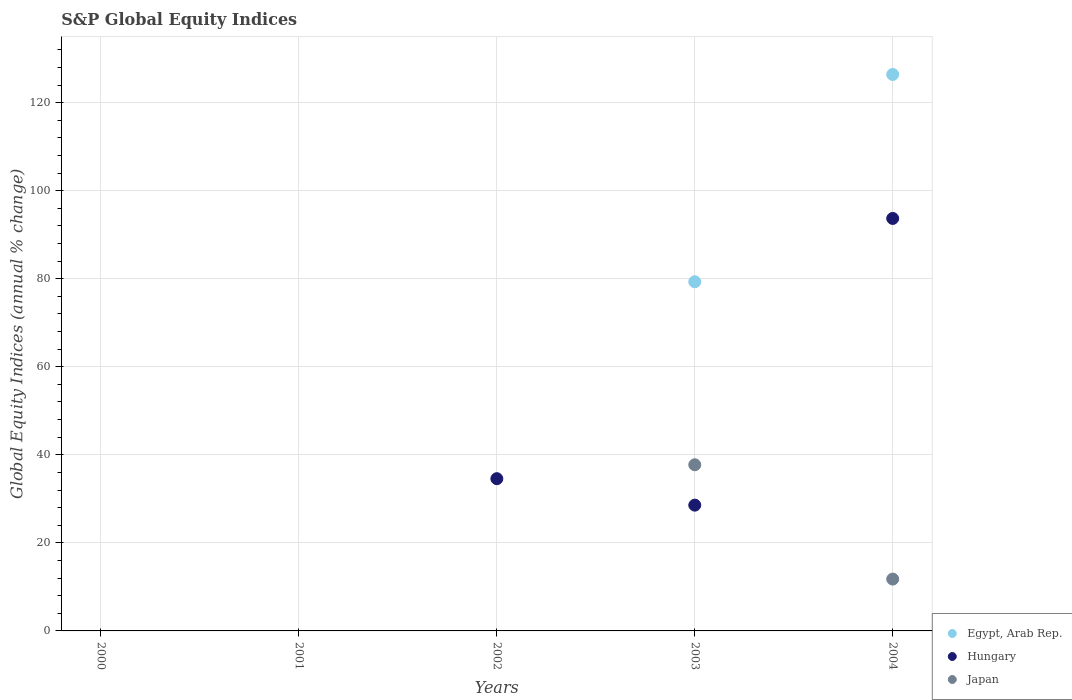What is the global equity indices in Egypt, Arab Rep. in 2004?
Ensure brevity in your answer.  126.4. Across all years, what is the maximum global equity indices in Hungary?
Your answer should be very brief. 93.69. What is the total global equity indices in Egypt, Arab Rep. in the graph?
Provide a succinct answer. 205.71. What is the difference between the global equity indices in Japan in 2003 and that in 2004?
Make the answer very short. 25.97. What is the difference between the global equity indices in Japan in 2000 and the global equity indices in Egypt, Arab Rep. in 2001?
Give a very brief answer. 0. What is the average global equity indices in Egypt, Arab Rep. per year?
Ensure brevity in your answer.  41.14. In the year 2003, what is the difference between the global equity indices in Japan and global equity indices in Hungary?
Ensure brevity in your answer.  9.17. What is the difference between the highest and the second highest global equity indices in Hungary?
Offer a very short reply. 59.11. What is the difference between the highest and the lowest global equity indices in Japan?
Your answer should be very brief. 37.74. Is it the case that in every year, the sum of the global equity indices in Egypt, Arab Rep. and global equity indices in Japan  is greater than the global equity indices in Hungary?
Keep it short and to the point. No. Is the global equity indices in Egypt, Arab Rep. strictly greater than the global equity indices in Japan over the years?
Offer a terse response. No. How many dotlines are there?
Offer a very short reply. 3. How many years are there in the graph?
Provide a short and direct response. 5. How many legend labels are there?
Provide a succinct answer. 3. What is the title of the graph?
Ensure brevity in your answer.  S&P Global Equity Indices. Does "Vietnam" appear as one of the legend labels in the graph?
Give a very brief answer. No. What is the label or title of the Y-axis?
Ensure brevity in your answer.  Global Equity Indices (annual % change). What is the Global Equity Indices (annual % change) of Japan in 2000?
Provide a succinct answer. 0. What is the Global Equity Indices (annual % change) in Egypt, Arab Rep. in 2001?
Provide a short and direct response. 0. What is the Global Equity Indices (annual % change) in Hungary in 2002?
Provide a succinct answer. 34.58. What is the Global Equity Indices (annual % change) in Egypt, Arab Rep. in 2003?
Your answer should be very brief. 79.31. What is the Global Equity Indices (annual % change) of Hungary in 2003?
Your response must be concise. 28.57. What is the Global Equity Indices (annual % change) in Japan in 2003?
Your answer should be very brief. 37.74. What is the Global Equity Indices (annual % change) of Egypt, Arab Rep. in 2004?
Your answer should be compact. 126.4. What is the Global Equity Indices (annual % change) of Hungary in 2004?
Make the answer very short. 93.69. What is the Global Equity Indices (annual % change) in Japan in 2004?
Provide a short and direct response. 11.77. Across all years, what is the maximum Global Equity Indices (annual % change) of Egypt, Arab Rep.?
Offer a terse response. 126.4. Across all years, what is the maximum Global Equity Indices (annual % change) in Hungary?
Make the answer very short. 93.69. Across all years, what is the maximum Global Equity Indices (annual % change) in Japan?
Your answer should be compact. 37.74. Across all years, what is the minimum Global Equity Indices (annual % change) in Hungary?
Keep it short and to the point. 0. Across all years, what is the minimum Global Equity Indices (annual % change) of Japan?
Ensure brevity in your answer.  0. What is the total Global Equity Indices (annual % change) in Egypt, Arab Rep. in the graph?
Make the answer very short. 205.71. What is the total Global Equity Indices (annual % change) of Hungary in the graph?
Offer a terse response. 156.84. What is the total Global Equity Indices (annual % change) of Japan in the graph?
Offer a very short reply. 49.51. What is the difference between the Global Equity Indices (annual % change) in Hungary in 2002 and that in 2003?
Your answer should be very brief. 6.01. What is the difference between the Global Equity Indices (annual % change) in Hungary in 2002 and that in 2004?
Provide a succinct answer. -59.11. What is the difference between the Global Equity Indices (annual % change) of Egypt, Arab Rep. in 2003 and that in 2004?
Give a very brief answer. -47.09. What is the difference between the Global Equity Indices (annual % change) of Hungary in 2003 and that in 2004?
Your answer should be compact. -65.12. What is the difference between the Global Equity Indices (annual % change) of Japan in 2003 and that in 2004?
Offer a very short reply. 25.97. What is the difference between the Global Equity Indices (annual % change) of Hungary in 2002 and the Global Equity Indices (annual % change) of Japan in 2003?
Ensure brevity in your answer.  -3.16. What is the difference between the Global Equity Indices (annual % change) of Hungary in 2002 and the Global Equity Indices (annual % change) of Japan in 2004?
Keep it short and to the point. 22.81. What is the difference between the Global Equity Indices (annual % change) of Egypt, Arab Rep. in 2003 and the Global Equity Indices (annual % change) of Hungary in 2004?
Your answer should be very brief. -14.38. What is the difference between the Global Equity Indices (annual % change) in Egypt, Arab Rep. in 2003 and the Global Equity Indices (annual % change) in Japan in 2004?
Make the answer very short. 67.54. What is the difference between the Global Equity Indices (annual % change) of Hungary in 2003 and the Global Equity Indices (annual % change) of Japan in 2004?
Ensure brevity in your answer.  16.8. What is the average Global Equity Indices (annual % change) in Egypt, Arab Rep. per year?
Your answer should be compact. 41.14. What is the average Global Equity Indices (annual % change) of Hungary per year?
Give a very brief answer. 31.37. What is the average Global Equity Indices (annual % change) in Japan per year?
Ensure brevity in your answer.  9.9. In the year 2003, what is the difference between the Global Equity Indices (annual % change) of Egypt, Arab Rep. and Global Equity Indices (annual % change) of Hungary?
Provide a succinct answer. 50.74. In the year 2003, what is the difference between the Global Equity Indices (annual % change) of Egypt, Arab Rep. and Global Equity Indices (annual % change) of Japan?
Make the answer very short. 41.57. In the year 2003, what is the difference between the Global Equity Indices (annual % change) in Hungary and Global Equity Indices (annual % change) in Japan?
Give a very brief answer. -9.17. In the year 2004, what is the difference between the Global Equity Indices (annual % change) of Egypt, Arab Rep. and Global Equity Indices (annual % change) of Hungary?
Offer a very short reply. 32.71. In the year 2004, what is the difference between the Global Equity Indices (annual % change) of Egypt, Arab Rep. and Global Equity Indices (annual % change) of Japan?
Give a very brief answer. 114.63. In the year 2004, what is the difference between the Global Equity Indices (annual % change) in Hungary and Global Equity Indices (annual % change) in Japan?
Offer a very short reply. 81.92. What is the ratio of the Global Equity Indices (annual % change) in Hungary in 2002 to that in 2003?
Provide a succinct answer. 1.21. What is the ratio of the Global Equity Indices (annual % change) of Hungary in 2002 to that in 2004?
Offer a terse response. 0.37. What is the ratio of the Global Equity Indices (annual % change) in Egypt, Arab Rep. in 2003 to that in 2004?
Keep it short and to the point. 0.63. What is the ratio of the Global Equity Indices (annual % change) of Hungary in 2003 to that in 2004?
Your answer should be compact. 0.3. What is the ratio of the Global Equity Indices (annual % change) of Japan in 2003 to that in 2004?
Offer a terse response. 3.21. What is the difference between the highest and the second highest Global Equity Indices (annual % change) of Hungary?
Your response must be concise. 59.11. What is the difference between the highest and the lowest Global Equity Indices (annual % change) of Egypt, Arab Rep.?
Give a very brief answer. 126.4. What is the difference between the highest and the lowest Global Equity Indices (annual % change) of Hungary?
Keep it short and to the point. 93.69. What is the difference between the highest and the lowest Global Equity Indices (annual % change) in Japan?
Offer a terse response. 37.74. 